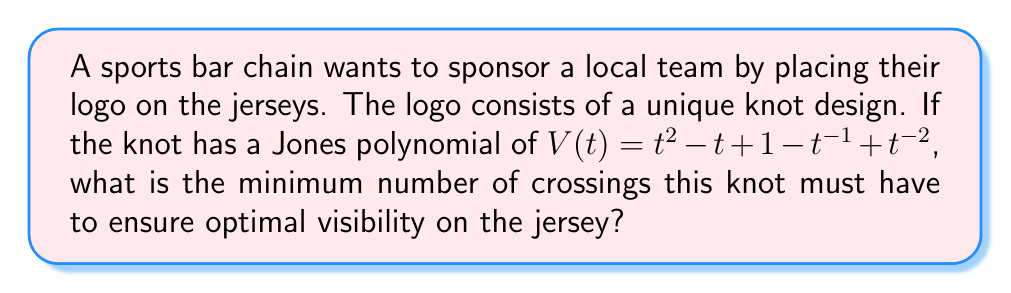What is the answer to this math problem? To determine the minimum number of crossings for the knot, we can use the following steps:

1. Recall that the Jones polynomial is a knot invariant that provides information about the knot's structure.

2. The degree span of the Jones polynomial is related to the crossing number of the knot. The degree span is defined as the difference between the highest and lowest exponents in the polynomial.

3. For the given Jones polynomial:
   $V(t) = t^2 - t + 1 - t^{-1} + t^{-2}$

4. Identify the highest exponent: 2
   Identify the lowest exponent: -2

5. Calculate the degree span:
   Degree span = Highest exponent - Lowest exponent
   Degree span = 2 - (-2) = 4

6. The Kaufmann-Murasugi-Thistlethwaite theorem states that for alternating knots, the crossing number is equal to the degree span of the Jones polynomial.

7. For non-alternating knots, the crossing number is always greater than or equal to the degree span.

8. Therefore, the minimum number of crossings for this knot is equal to the degree span, which is 4.

This ensures optimal visibility on the jersey while maintaining the unique characteristics of the logo's knot design.
Answer: 4 crossings 